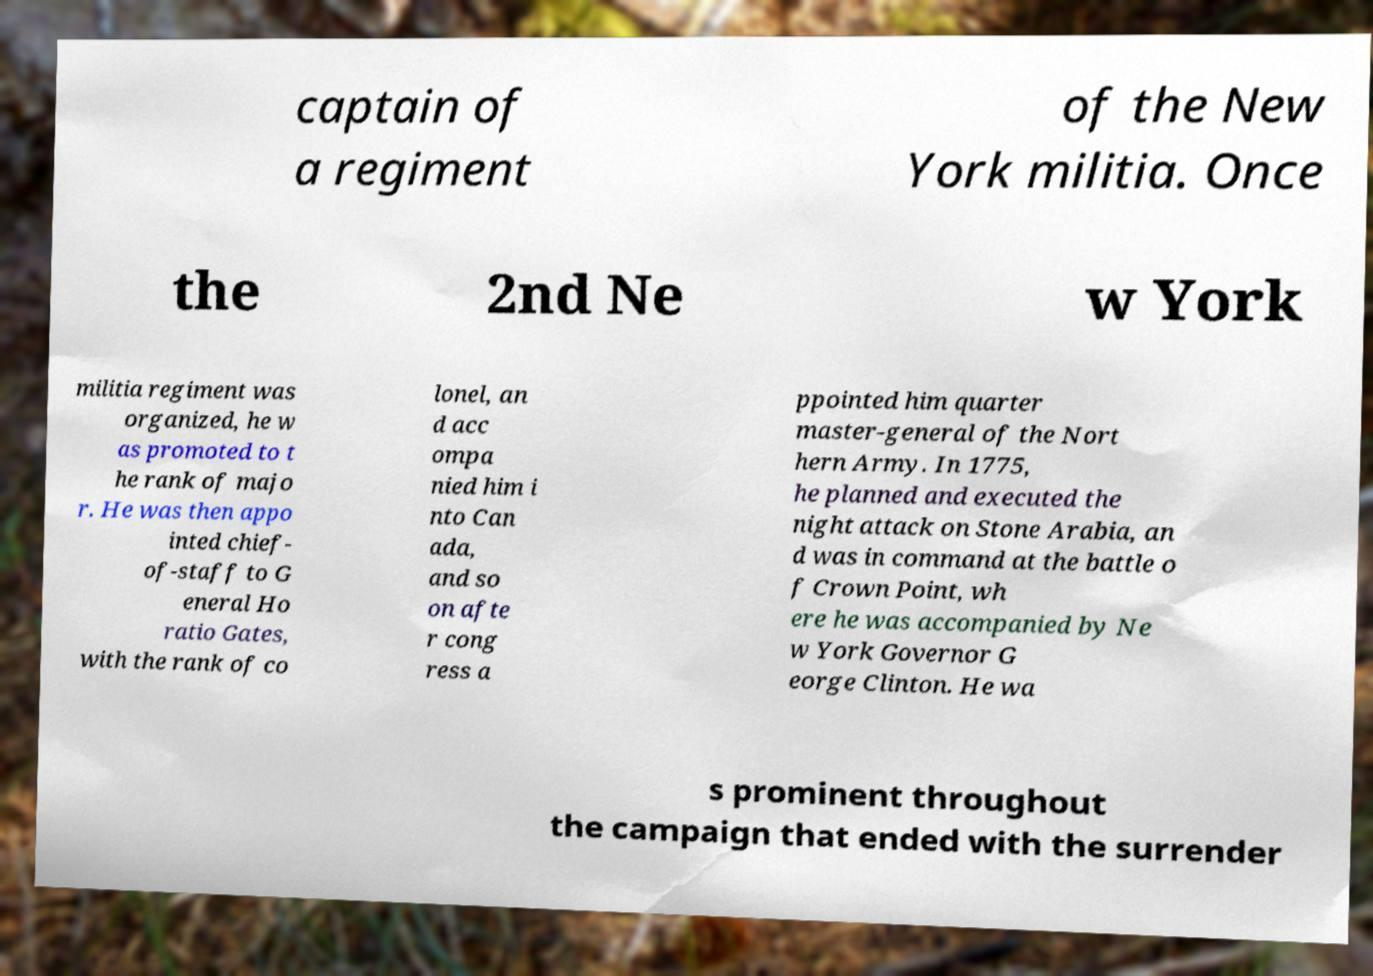For documentation purposes, I need the text within this image transcribed. Could you provide that? captain of a regiment of the New York militia. Once the 2nd Ne w York militia regiment was organized, he w as promoted to t he rank of majo r. He was then appo inted chief- of-staff to G eneral Ho ratio Gates, with the rank of co lonel, an d acc ompa nied him i nto Can ada, and so on afte r cong ress a ppointed him quarter master-general of the Nort hern Army. In 1775, he planned and executed the night attack on Stone Arabia, an d was in command at the battle o f Crown Point, wh ere he was accompanied by Ne w York Governor G eorge Clinton. He wa s prominent throughout the campaign that ended with the surrender 